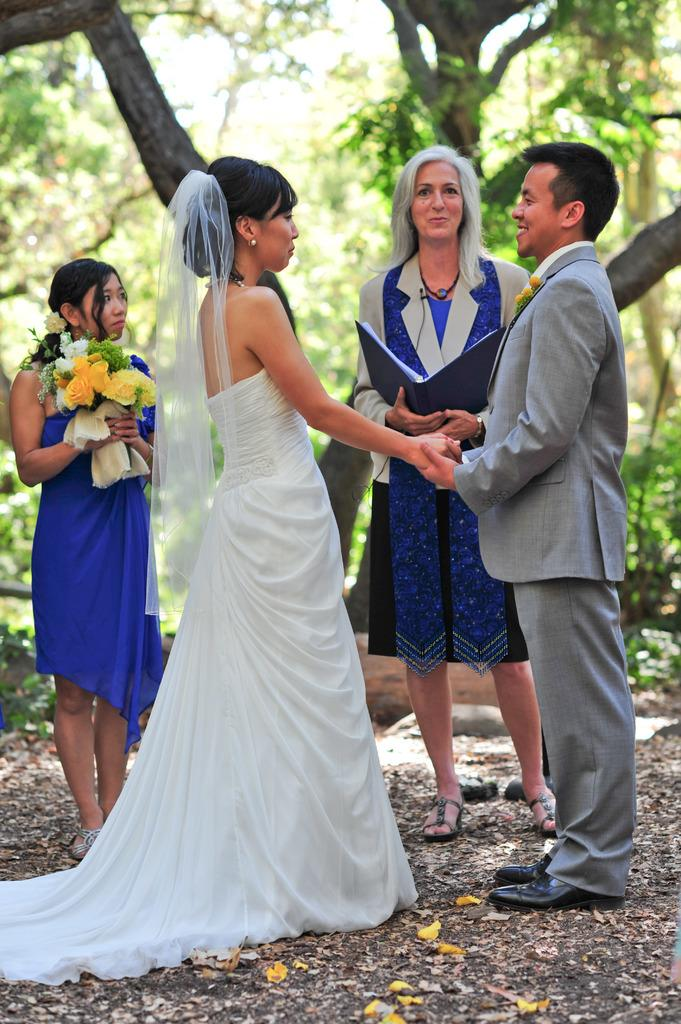What is the woman on the left side of the image holding? The woman on the left side of the image is holding a book. What is the woman on the right side of the image holding? The woman on the right side of the image is holding a bouquet. What can be seen in the background of the image? There are trees present in the background of the image. What is the relationship between the two women in the image? The two women are part of a couple standing together. What type of pear is being used as a prop in the image? There is no pear present in the image. What kind of laborer can be seen working in the background of the image? There is no laborer present in the image; it features two women and trees in the background. 